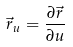<formula> <loc_0><loc_0><loc_500><loc_500>\vec { r } _ { u } = \frac { \partial \vec { r } } { \partial u }</formula> 